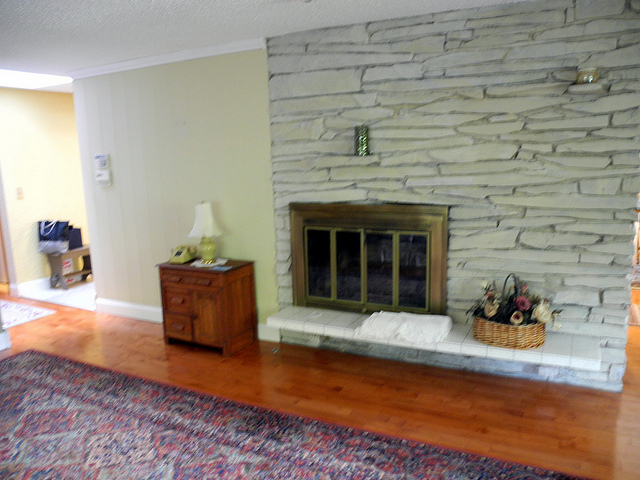<image>What does the brass container on the left side of the fireplace most likely contain? It is unknown what the brass container on the left side of the fireplace most likely contains. It could contain flowers, ashes, wood, poker, matches or pokers. What red object is that on the floor? I am not sure what the red object is. It could be a carpet, a rug, or a stand. What does the brass container on the left side of the fireplace most likely contain? I am not sure what the brass container on the left side of the fireplace most likely contains. It can be flowers, ashes, wood, or matches. What red object is that on the floor? I am not sure what red object is on the floor. It can be seen as 'carpet', 'rug', or 'stand'. 